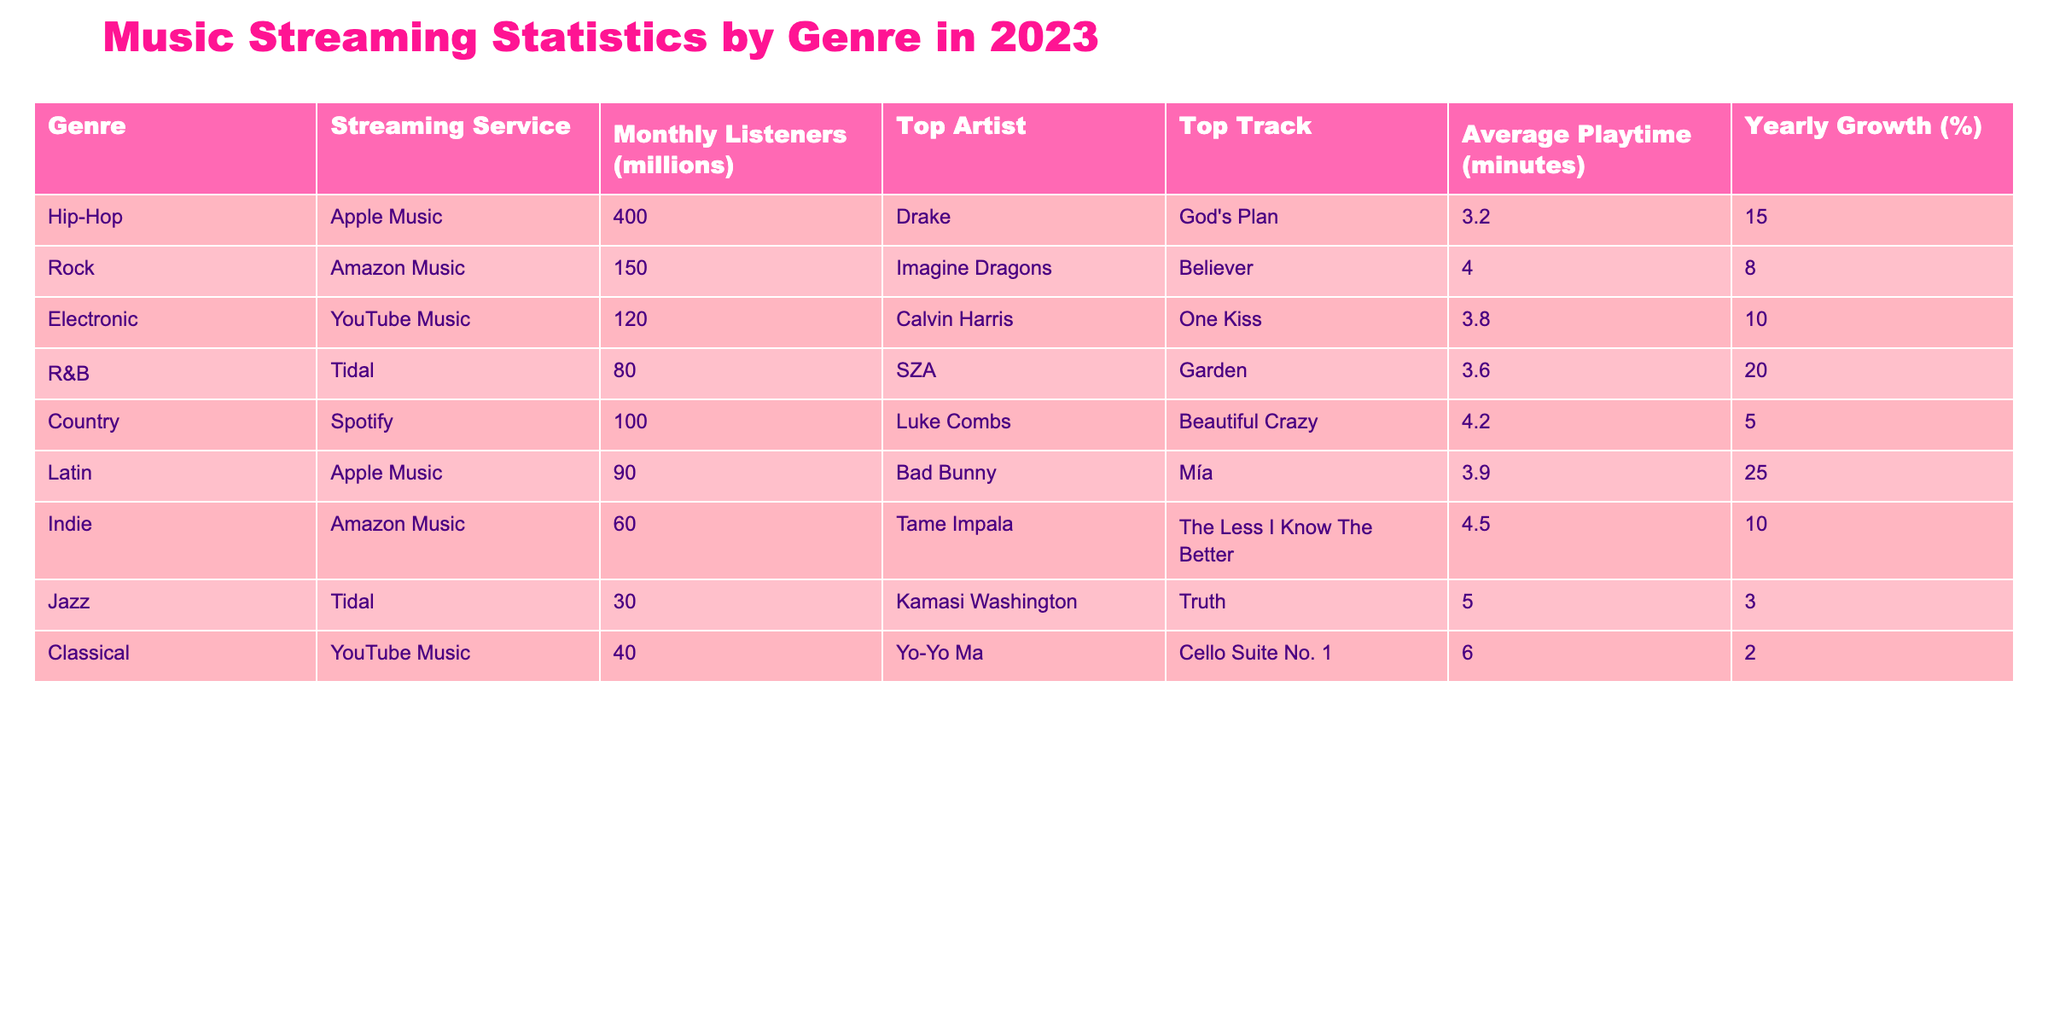What's the top artist in the Hip-Hop genre? The table specifies that the top artist in the Hip-Hop genre is Drake.
Answer: Drake Which streaming service has the highest monthly listeners for R&B? According to the table, Tidal has the highest monthly listeners for R&B at 80 million.
Answer: Tidal What is the average playtime for Classical music tracks? The average playtime listed for Classical music tracks is 6.0 minutes, as shown in the table.
Answer: 6.0 How many monthly listeners does Latin music have? The table states that Latin music has 90 million monthly listeners.
Answer: 90 million What genre has the highest yearly growth percentage? The table shows that Latin music has the highest yearly growth percentage at 25%.
Answer: 25% Is R&B music more popular than Electronic music in terms of monthly listeners? Yes, R&B has 80 million listeners while Electronic has 120 million; therefore, R&B is less popular.
Answer: No Which genre has the lowest average playtime? The table lists the Jazz genre with the lowest average playtime of 5.0 minutes.
Answer: Jazz What are the total monthly listeners across all genres listed? To find this, we sum all monthly listeners: 400 + 150 + 120 + 80 + 100 + 90 + 60 + 30 + 40 = 1,070 million.
Answer: 1,070 million If we only consider the top three genres by monthly listeners, who are the top three artists? The top three genres are Hip-Hop (Drake), Rock (Imagine Dragons), and Electronic (Calvin Harris), based on their monthly listener counts.
Answer: Drake, Imagine Dragons, Calvin Harris What is the difference in average playtime between Electronic and Country genres? Electronic music has an average playtime of 3.8 minutes and Country has 4.2 minutes; the difference is 4.2 - 3.8 = 0.4 minutes.
Answer: 0.4 minutes 